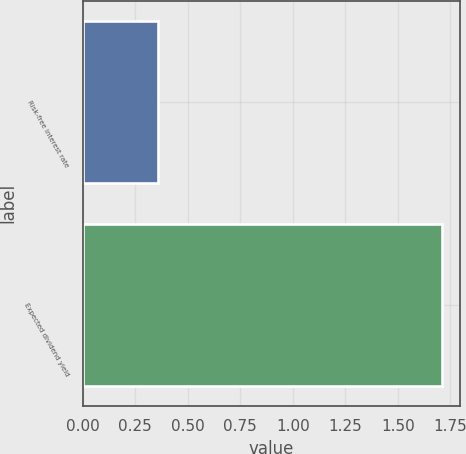Convert chart to OTSL. <chart><loc_0><loc_0><loc_500><loc_500><bar_chart><fcel>Risk-free interest rate<fcel>Expected dividend yield<nl><fcel>0.36<fcel>1.71<nl></chart> 